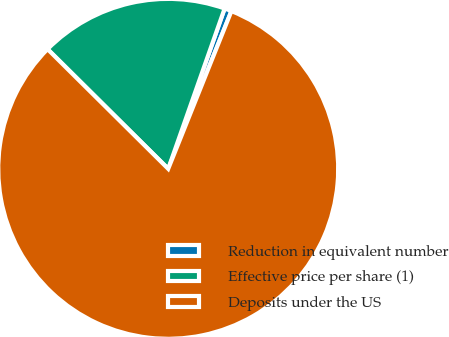Convert chart to OTSL. <chart><loc_0><loc_0><loc_500><loc_500><pie_chart><fcel>Reduction in equivalent number<fcel>Effective price per share (1)<fcel>Deposits under the US<nl><fcel>0.68%<fcel>17.95%<fcel>81.38%<nl></chart> 